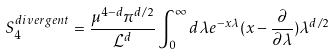<formula> <loc_0><loc_0><loc_500><loc_500>S _ { 4 } ^ { d i v e r g e n t } = \frac { \mu ^ { 4 - d } \pi ^ { d / 2 } } { { \mathcal { L } } ^ { d } } \int _ { 0 } ^ { \infty } d \lambda e ^ { - x \lambda } ( x - \frac { \partial } { \partial \lambda } ) \lambda ^ { d / 2 }</formula> 